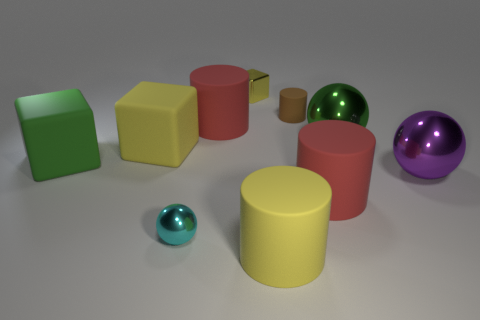Subtract all blocks. How many objects are left? 7 Add 6 large yellow matte things. How many large yellow matte things are left? 8 Add 9 tiny yellow things. How many tiny yellow things exist? 10 Subtract 0 gray spheres. How many objects are left? 10 Subtract all purple shiny spheres. Subtract all large yellow matte cylinders. How many objects are left? 8 